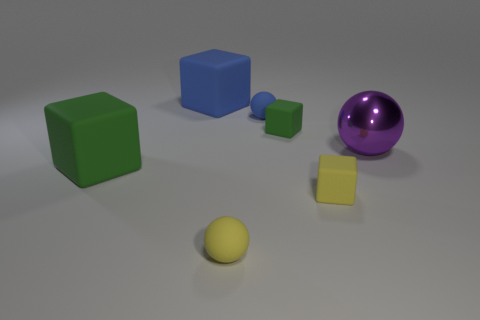What color is the other tiny cube that is the same material as the tiny green cube?
Your response must be concise. Yellow. What number of large things are either gray spheres or metallic things?
Your response must be concise. 1. How many large purple metal balls are on the left side of the purple object?
Provide a short and direct response. 0. There is another big object that is the same shape as the big green rubber object; what is its color?
Make the answer very short. Blue. How many rubber objects are either green objects or purple balls?
Provide a short and direct response. 2. Is there a matte ball behind the small ball in front of the large object that is on the left side of the big blue block?
Ensure brevity in your answer.  Yes. What is the color of the large metallic object?
Keep it short and to the point. Purple. Do the tiny yellow thing behind the yellow ball and the purple shiny thing have the same shape?
Your answer should be compact. No. How many objects are big blue things or blocks that are to the left of the yellow block?
Your answer should be very brief. 3. Are the big cube in front of the tiny blue ball and the yellow block made of the same material?
Provide a succinct answer. Yes. 